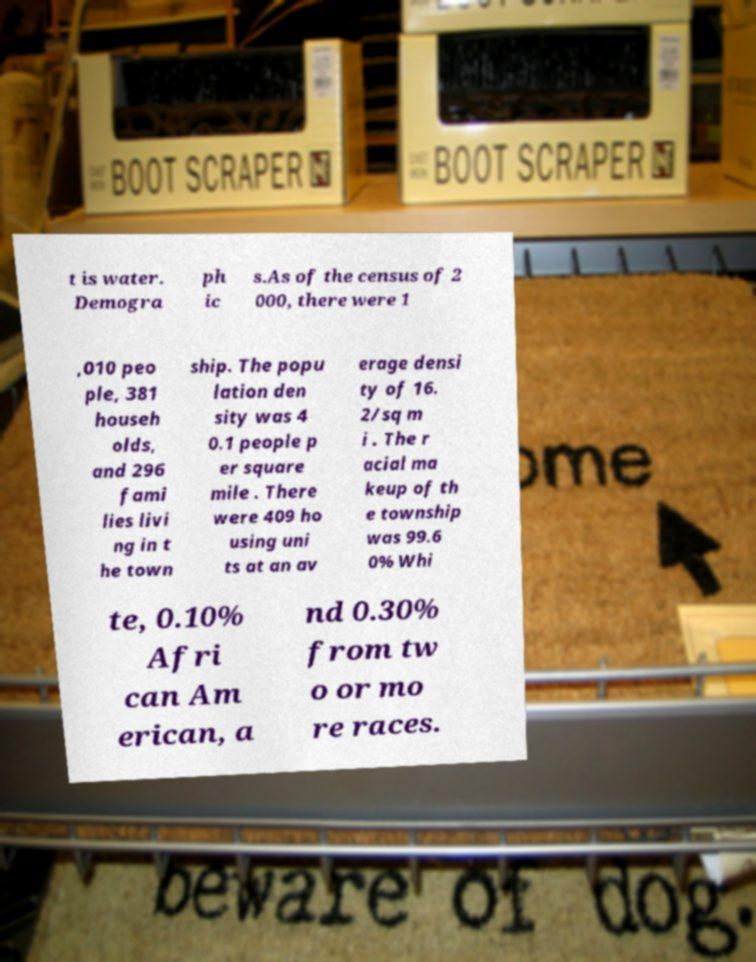Could you extract and type out the text from this image? t is water. Demogra ph ic s.As of the census of 2 000, there were 1 ,010 peo ple, 381 househ olds, and 296 fami lies livi ng in t he town ship. The popu lation den sity was 4 0.1 people p er square mile . There were 409 ho using uni ts at an av erage densi ty of 16. 2/sq m i . The r acial ma keup of th e township was 99.6 0% Whi te, 0.10% Afri can Am erican, a nd 0.30% from tw o or mo re races. 